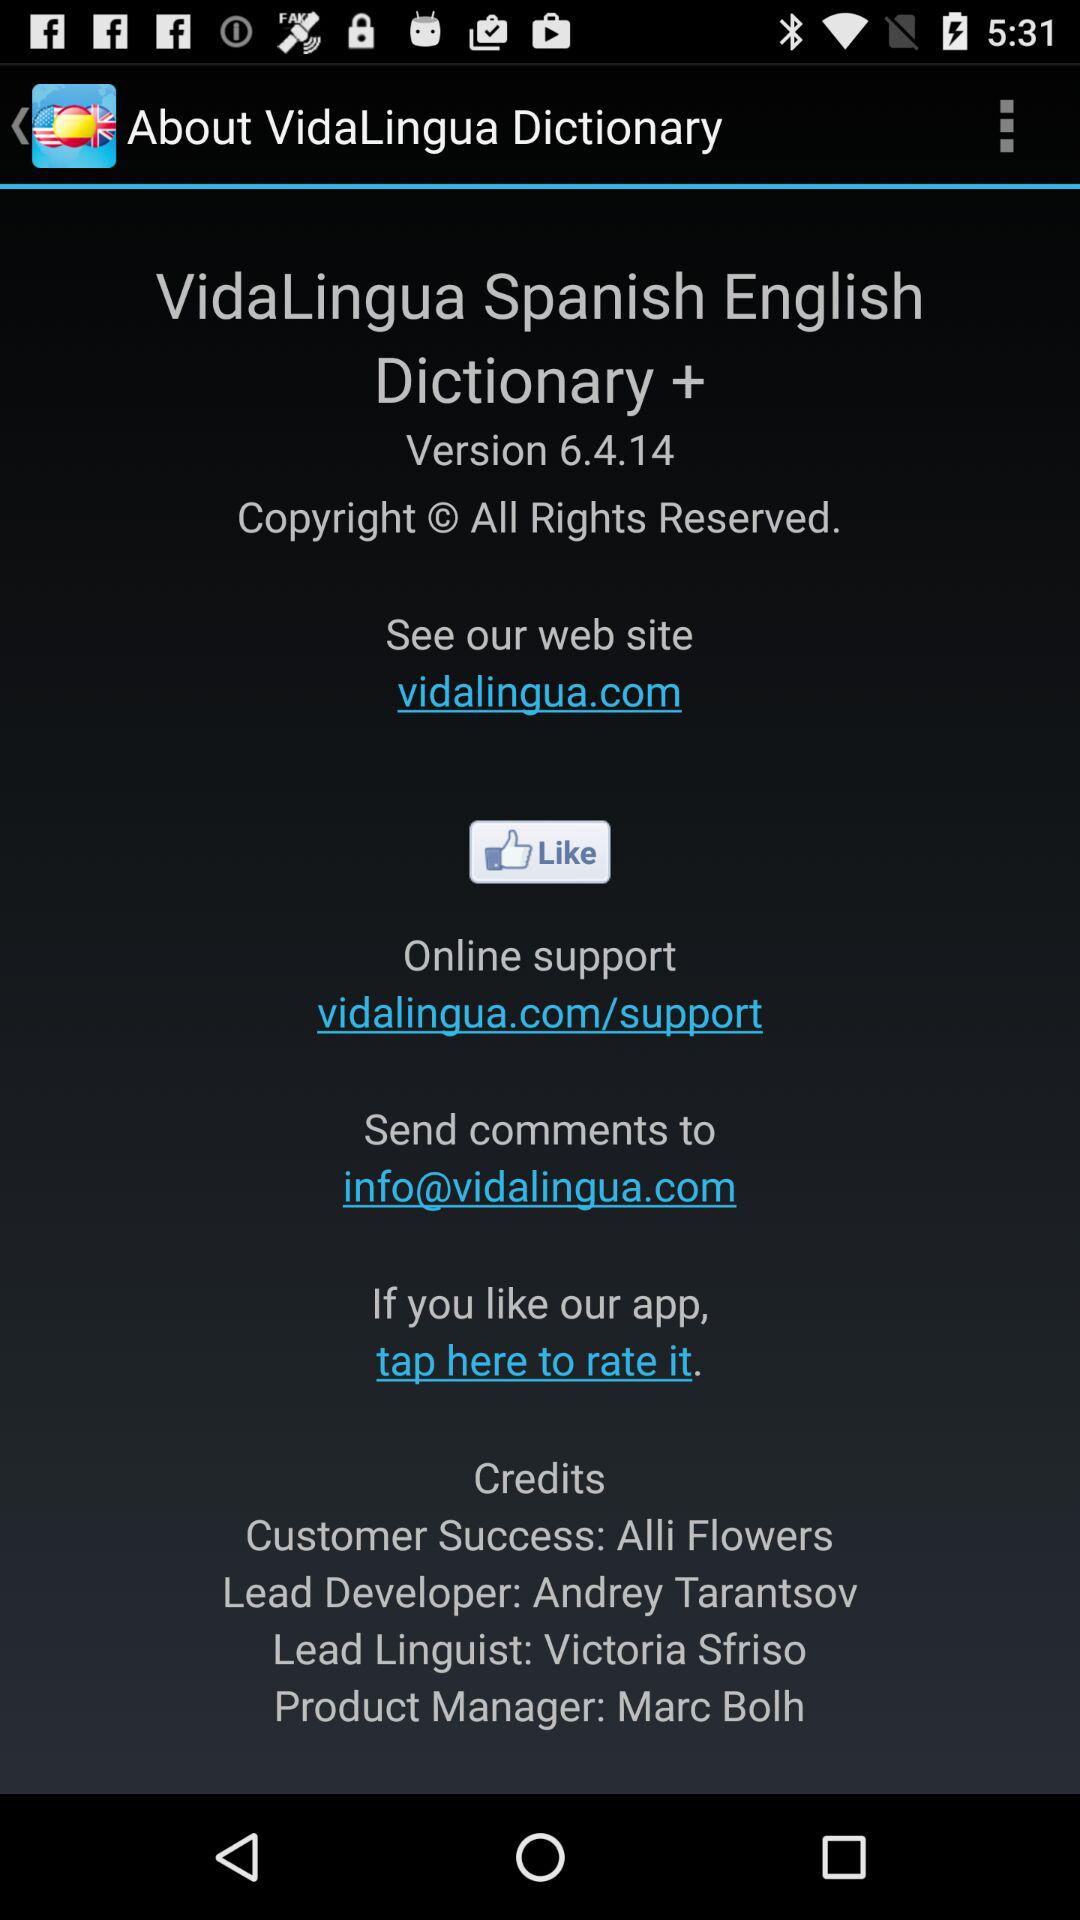What is the version? The version is 6.4.14. 